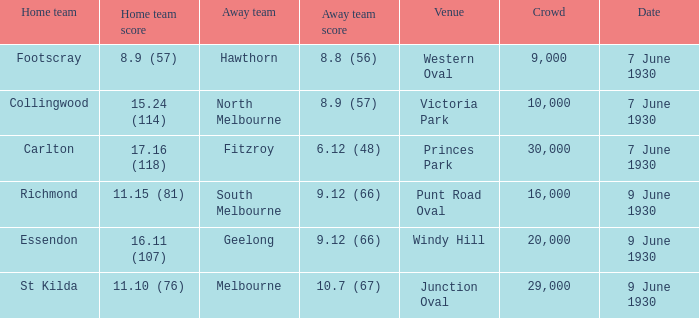What is the least number of people who saw the away team achieve a score of 10.7 (67)? 29000.0. 